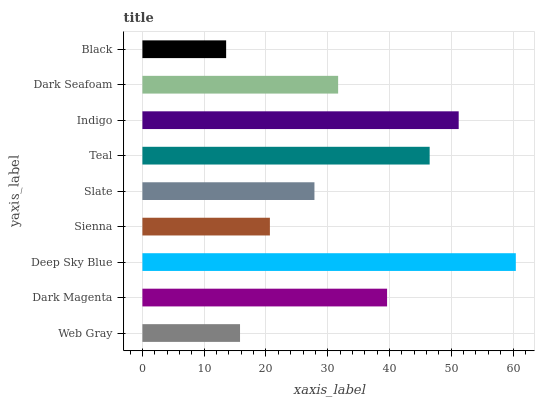Is Black the minimum?
Answer yes or no. Yes. Is Deep Sky Blue the maximum?
Answer yes or no. Yes. Is Dark Magenta the minimum?
Answer yes or no. No. Is Dark Magenta the maximum?
Answer yes or no. No. Is Dark Magenta greater than Web Gray?
Answer yes or no. Yes. Is Web Gray less than Dark Magenta?
Answer yes or no. Yes. Is Web Gray greater than Dark Magenta?
Answer yes or no. No. Is Dark Magenta less than Web Gray?
Answer yes or no. No. Is Dark Seafoam the high median?
Answer yes or no. Yes. Is Dark Seafoam the low median?
Answer yes or no. Yes. Is Indigo the high median?
Answer yes or no. No. Is Sienna the low median?
Answer yes or no. No. 